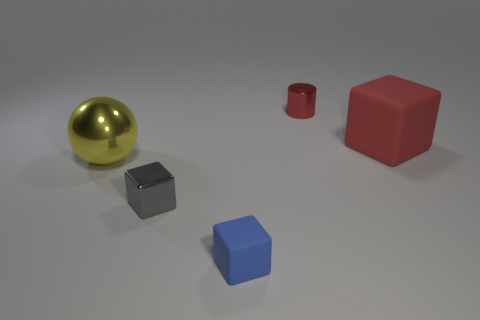Is the color of the large block the same as the tiny metallic cylinder?
Give a very brief answer. Yes. Is the big ball on the left side of the big red matte cube made of the same material as the blue block that is in front of the big red thing?
Provide a succinct answer. No. Are there any blocks of the same size as the yellow object?
Your answer should be compact. Yes. What size is the yellow sphere in front of the large object on the right side of the gray metal cube?
Offer a very short reply. Large. How many rubber blocks have the same color as the cylinder?
Offer a terse response. 1. There is a small shiny object on the right side of the tiny block behind the blue cube; what is its shape?
Your response must be concise. Cylinder. What number of large objects have the same material as the tiny gray thing?
Keep it short and to the point. 1. What material is the small red thing that is on the right side of the gray shiny object?
Keep it short and to the point. Metal. What shape is the tiny shiny thing that is on the right side of the blue rubber object in front of the tiny block that is left of the small matte thing?
Offer a terse response. Cylinder. Is the color of the matte cube in front of the red matte object the same as the tiny cube behind the tiny matte thing?
Your answer should be compact. No. 